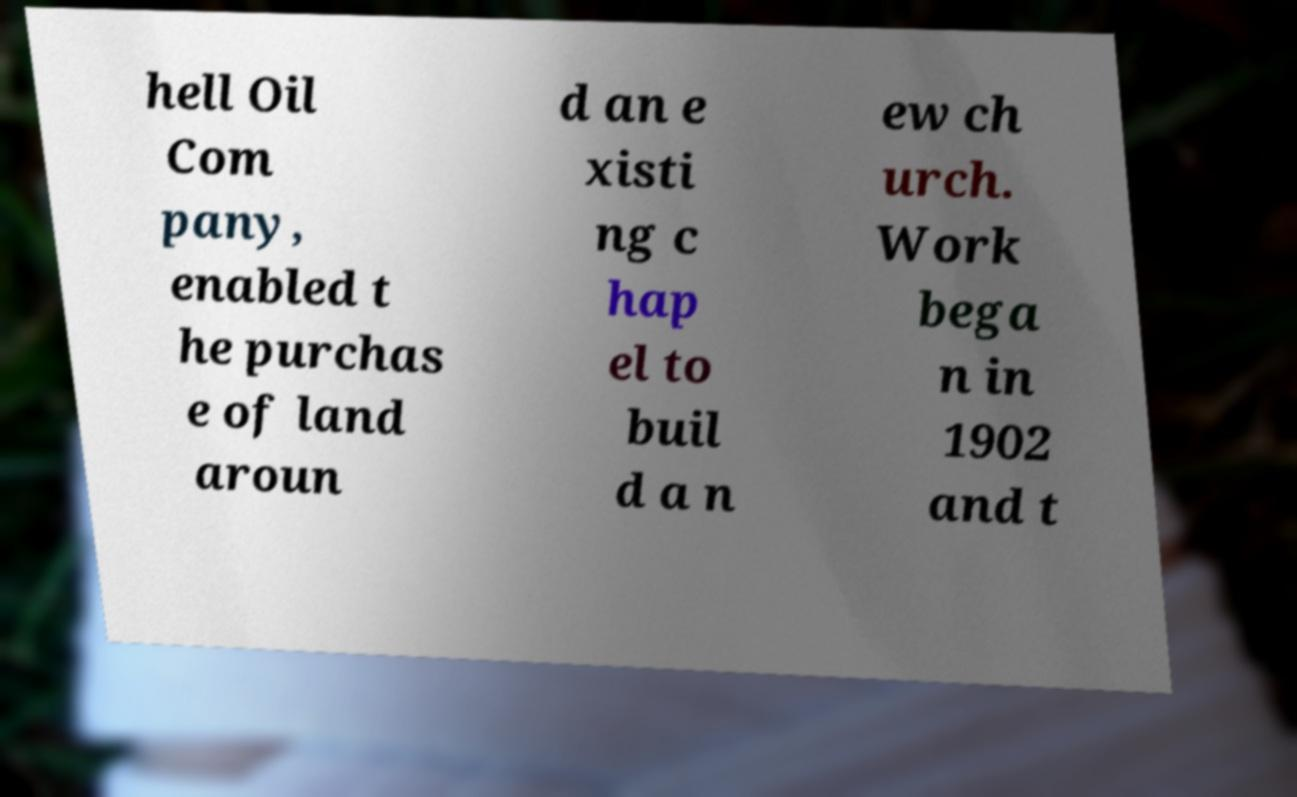Can you accurately transcribe the text from the provided image for me? hell Oil Com pany, enabled t he purchas e of land aroun d an e xisti ng c hap el to buil d a n ew ch urch. Work bega n in 1902 and t 